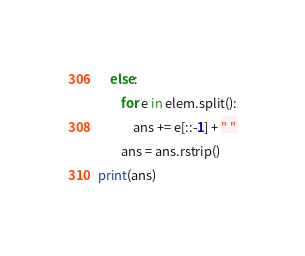<code> <loc_0><loc_0><loc_500><loc_500><_Python_>    else:
        for e in elem.split():
            ans += e[::-1] + " "
        ans = ans.rstrip()
print(ans)</code> 